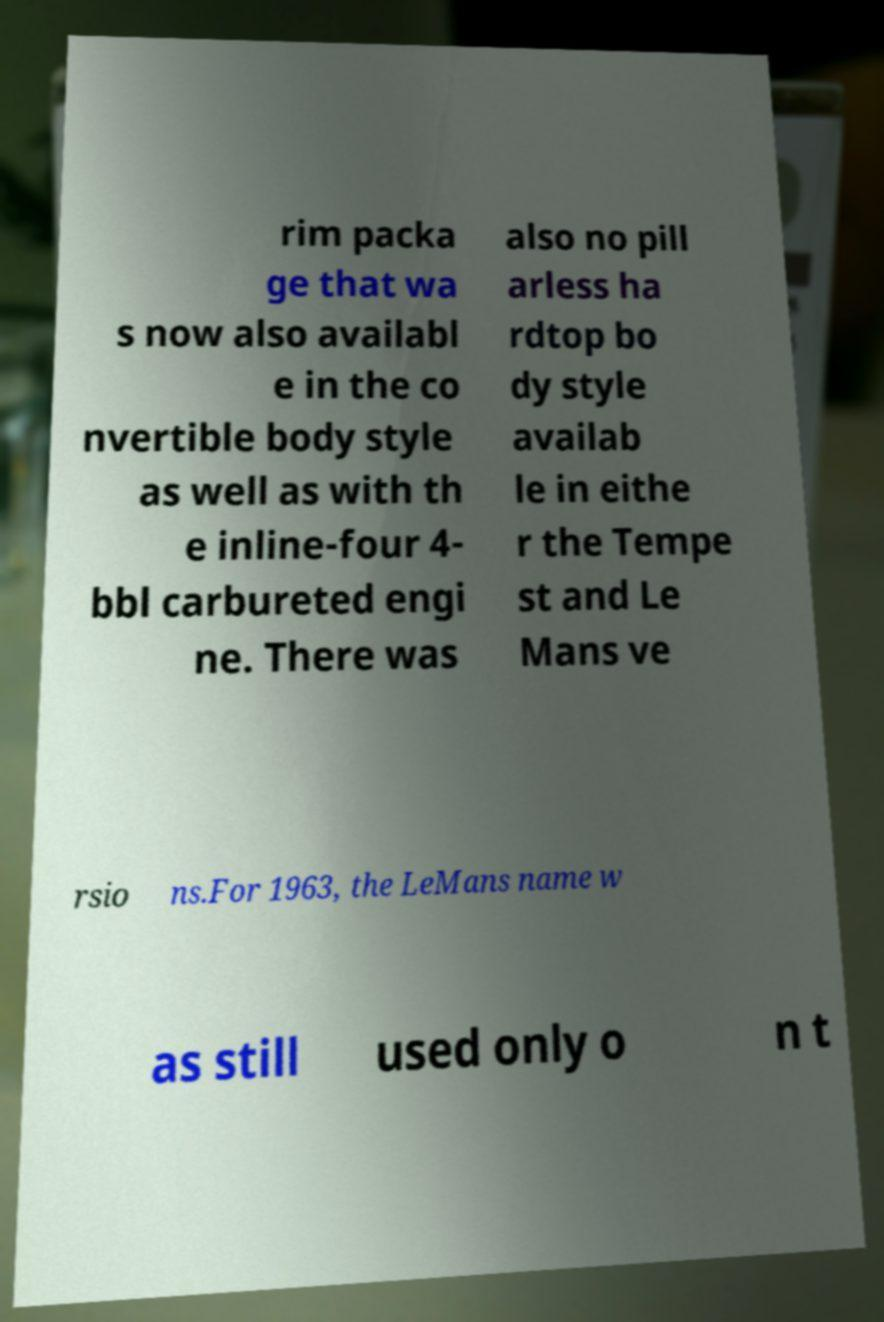Can you read and provide the text displayed in the image?This photo seems to have some interesting text. Can you extract and type it out for me? rim packa ge that wa s now also availabl e in the co nvertible body style as well as with th e inline-four 4- bbl carbureted engi ne. There was also no pill arless ha rdtop bo dy style availab le in eithe r the Tempe st and Le Mans ve rsio ns.For 1963, the LeMans name w as still used only o n t 